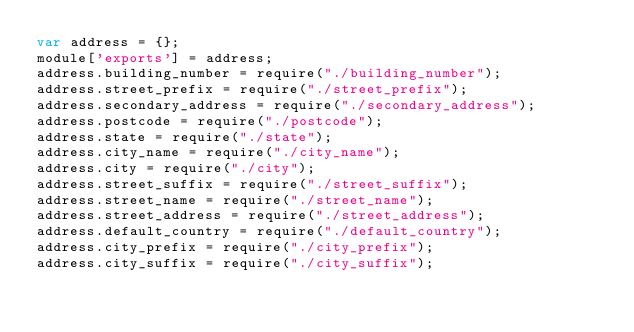<code> <loc_0><loc_0><loc_500><loc_500><_JavaScript_>var address = {};
module['exports'] = address;
address.building_number = require("./building_number");
address.street_prefix = require("./street_prefix");
address.secondary_address = require("./secondary_address");
address.postcode = require("./postcode");
address.state = require("./state");
address.city_name = require("./city_name");
address.city = require("./city");
address.street_suffix = require("./street_suffix");
address.street_name = require("./street_name");
address.street_address = require("./street_address");
address.default_country = require("./default_country");
address.city_prefix = require("./city_prefix");
address.city_suffix = require("./city_suffix");
</code> 